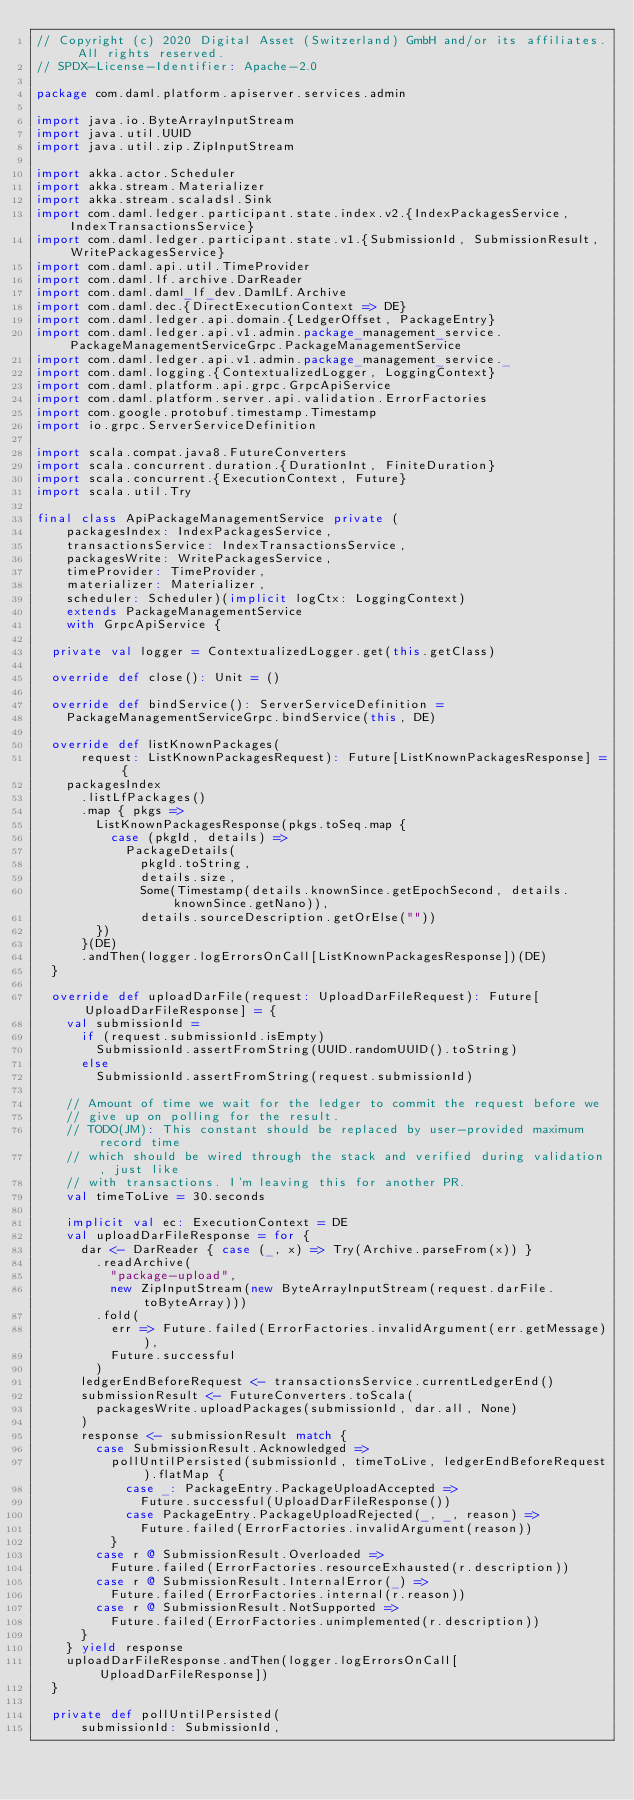<code> <loc_0><loc_0><loc_500><loc_500><_Scala_>// Copyright (c) 2020 Digital Asset (Switzerland) GmbH and/or its affiliates. All rights reserved.
// SPDX-License-Identifier: Apache-2.0

package com.daml.platform.apiserver.services.admin

import java.io.ByteArrayInputStream
import java.util.UUID
import java.util.zip.ZipInputStream

import akka.actor.Scheduler
import akka.stream.Materializer
import akka.stream.scaladsl.Sink
import com.daml.ledger.participant.state.index.v2.{IndexPackagesService, IndexTransactionsService}
import com.daml.ledger.participant.state.v1.{SubmissionId, SubmissionResult, WritePackagesService}
import com.daml.api.util.TimeProvider
import com.daml.lf.archive.DarReader
import com.daml.daml_lf_dev.DamlLf.Archive
import com.daml.dec.{DirectExecutionContext => DE}
import com.daml.ledger.api.domain.{LedgerOffset, PackageEntry}
import com.daml.ledger.api.v1.admin.package_management_service.PackageManagementServiceGrpc.PackageManagementService
import com.daml.ledger.api.v1.admin.package_management_service._
import com.daml.logging.{ContextualizedLogger, LoggingContext}
import com.daml.platform.api.grpc.GrpcApiService
import com.daml.platform.server.api.validation.ErrorFactories
import com.google.protobuf.timestamp.Timestamp
import io.grpc.ServerServiceDefinition

import scala.compat.java8.FutureConverters
import scala.concurrent.duration.{DurationInt, FiniteDuration}
import scala.concurrent.{ExecutionContext, Future}
import scala.util.Try

final class ApiPackageManagementService private (
    packagesIndex: IndexPackagesService,
    transactionsService: IndexTransactionsService,
    packagesWrite: WritePackagesService,
    timeProvider: TimeProvider,
    materializer: Materializer,
    scheduler: Scheduler)(implicit logCtx: LoggingContext)
    extends PackageManagementService
    with GrpcApiService {

  private val logger = ContextualizedLogger.get(this.getClass)

  override def close(): Unit = ()

  override def bindService(): ServerServiceDefinition =
    PackageManagementServiceGrpc.bindService(this, DE)

  override def listKnownPackages(
      request: ListKnownPackagesRequest): Future[ListKnownPackagesResponse] = {
    packagesIndex
      .listLfPackages()
      .map { pkgs =>
        ListKnownPackagesResponse(pkgs.toSeq.map {
          case (pkgId, details) =>
            PackageDetails(
              pkgId.toString,
              details.size,
              Some(Timestamp(details.knownSince.getEpochSecond, details.knownSince.getNano)),
              details.sourceDescription.getOrElse(""))
        })
      }(DE)
      .andThen(logger.logErrorsOnCall[ListKnownPackagesResponse])(DE)
  }

  override def uploadDarFile(request: UploadDarFileRequest): Future[UploadDarFileResponse] = {
    val submissionId =
      if (request.submissionId.isEmpty)
        SubmissionId.assertFromString(UUID.randomUUID().toString)
      else
        SubmissionId.assertFromString(request.submissionId)

    // Amount of time we wait for the ledger to commit the request before we
    // give up on polling for the result.
    // TODO(JM): This constant should be replaced by user-provided maximum record time
    // which should be wired through the stack and verified during validation, just like
    // with transactions. I'm leaving this for another PR.
    val timeToLive = 30.seconds

    implicit val ec: ExecutionContext = DE
    val uploadDarFileResponse = for {
      dar <- DarReader { case (_, x) => Try(Archive.parseFrom(x)) }
        .readArchive(
          "package-upload",
          new ZipInputStream(new ByteArrayInputStream(request.darFile.toByteArray)))
        .fold(
          err => Future.failed(ErrorFactories.invalidArgument(err.getMessage)),
          Future.successful
        )
      ledgerEndBeforeRequest <- transactionsService.currentLedgerEnd()
      submissionResult <- FutureConverters.toScala(
        packagesWrite.uploadPackages(submissionId, dar.all, None)
      )
      response <- submissionResult match {
        case SubmissionResult.Acknowledged =>
          pollUntilPersisted(submissionId, timeToLive, ledgerEndBeforeRequest).flatMap {
            case _: PackageEntry.PackageUploadAccepted =>
              Future.successful(UploadDarFileResponse())
            case PackageEntry.PackageUploadRejected(_, _, reason) =>
              Future.failed(ErrorFactories.invalidArgument(reason))
          }
        case r @ SubmissionResult.Overloaded =>
          Future.failed(ErrorFactories.resourceExhausted(r.description))
        case r @ SubmissionResult.InternalError(_) =>
          Future.failed(ErrorFactories.internal(r.reason))
        case r @ SubmissionResult.NotSupported =>
          Future.failed(ErrorFactories.unimplemented(r.description))
      }
    } yield response
    uploadDarFileResponse.andThen(logger.logErrorsOnCall[UploadDarFileResponse])
  }

  private def pollUntilPersisted(
      submissionId: SubmissionId,</code> 